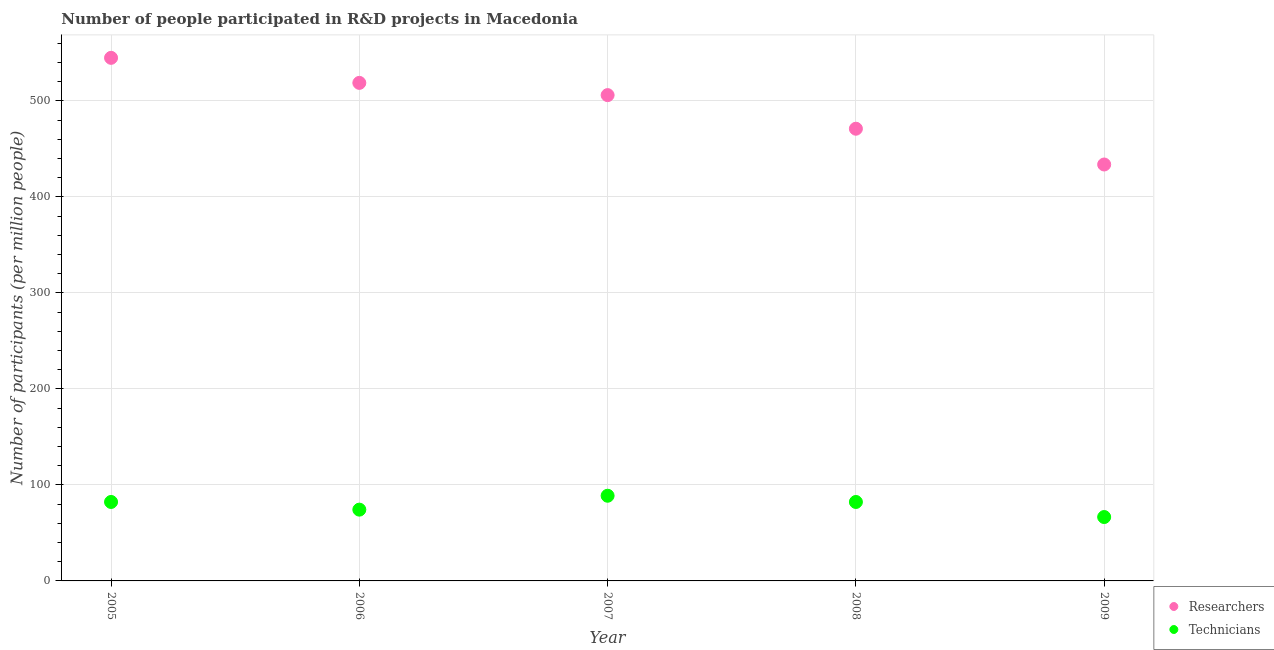What is the number of technicians in 2009?
Your response must be concise. 66.54. Across all years, what is the maximum number of technicians?
Give a very brief answer. 88.72. Across all years, what is the minimum number of researchers?
Provide a succinct answer. 433.72. What is the total number of researchers in the graph?
Your answer should be compact. 2474.24. What is the difference between the number of technicians in 2005 and that in 2007?
Offer a very short reply. -6.48. What is the difference between the number of researchers in 2007 and the number of technicians in 2005?
Keep it short and to the point. 423.75. What is the average number of technicians per year?
Your response must be concise. 78.79. In the year 2005, what is the difference between the number of researchers and number of technicians?
Offer a terse response. 462.58. In how many years, is the number of researchers greater than 100?
Make the answer very short. 5. What is the ratio of the number of researchers in 2007 to that in 2008?
Offer a terse response. 1.07. What is the difference between the highest and the second highest number of researchers?
Give a very brief answer. 26.09. What is the difference between the highest and the lowest number of researchers?
Your response must be concise. 111.09. Is the number of researchers strictly less than the number of technicians over the years?
Offer a very short reply. No. How many dotlines are there?
Offer a terse response. 2. How many years are there in the graph?
Make the answer very short. 5. Does the graph contain any zero values?
Keep it short and to the point. No. Does the graph contain grids?
Ensure brevity in your answer.  Yes. Where does the legend appear in the graph?
Your response must be concise. Bottom right. How many legend labels are there?
Offer a terse response. 2. How are the legend labels stacked?
Your answer should be compact. Vertical. What is the title of the graph?
Offer a very short reply. Number of people participated in R&D projects in Macedonia. What is the label or title of the Y-axis?
Offer a very short reply. Number of participants (per million people). What is the Number of participants (per million people) of Researchers in 2005?
Provide a short and direct response. 544.82. What is the Number of participants (per million people) of Technicians in 2005?
Give a very brief answer. 82.24. What is the Number of participants (per million people) of Researchers in 2006?
Give a very brief answer. 518.72. What is the Number of participants (per million people) of Technicians in 2006?
Offer a terse response. 74.24. What is the Number of participants (per million people) in Researchers in 2007?
Keep it short and to the point. 505.99. What is the Number of participants (per million people) of Technicians in 2007?
Provide a succinct answer. 88.72. What is the Number of participants (per million people) of Researchers in 2008?
Your response must be concise. 470.99. What is the Number of participants (per million people) of Technicians in 2008?
Your response must be concise. 82.23. What is the Number of participants (per million people) of Researchers in 2009?
Your answer should be very brief. 433.72. What is the Number of participants (per million people) of Technicians in 2009?
Provide a succinct answer. 66.54. Across all years, what is the maximum Number of participants (per million people) in Researchers?
Keep it short and to the point. 544.82. Across all years, what is the maximum Number of participants (per million people) of Technicians?
Ensure brevity in your answer.  88.72. Across all years, what is the minimum Number of participants (per million people) in Researchers?
Offer a very short reply. 433.72. Across all years, what is the minimum Number of participants (per million people) of Technicians?
Your answer should be compact. 66.54. What is the total Number of participants (per million people) in Researchers in the graph?
Offer a very short reply. 2474.24. What is the total Number of participants (per million people) in Technicians in the graph?
Give a very brief answer. 393.97. What is the difference between the Number of participants (per million people) in Researchers in 2005 and that in 2006?
Your answer should be compact. 26.09. What is the difference between the Number of participants (per million people) in Technicians in 2005 and that in 2006?
Provide a short and direct response. 7.99. What is the difference between the Number of participants (per million people) of Researchers in 2005 and that in 2007?
Your answer should be compact. 38.83. What is the difference between the Number of participants (per million people) of Technicians in 2005 and that in 2007?
Provide a short and direct response. -6.48. What is the difference between the Number of participants (per million people) of Researchers in 2005 and that in 2008?
Your answer should be compact. 73.83. What is the difference between the Number of participants (per million people) in Technicians in 2005 and that in 2008?
Make the answer very short. 0.01. What is the difference between the Number of participants (per million people) of Researchers in 2005 and that in 2009?
Provide a short and direct response. 111.09. What is the difference between the Number of participants (per million people) of Technicians in 2005 and that in 2009?
Keep it short and to the point. 15.7. What is the difference between the Number of participants (per million people) in Researchers in 2006 and that in 2007?
Keep it short and to the point. 12.74. What is the difference between the Number of participants (per million people) of Technicians in 2006 and that in 2007?
Offer a very short reply. -14.48. What is the difference between the Number of participants (per million people) of Researchers in 2006 and that in 2008?
Give a very brief answer. 47.74. What is the difference between the Number of participants (per million people) in Technicians in 2006 and that in 2008?
Your answer should be very brief. -7.98. What is the difference between the Number of participants (per million people) of Researchers in 2006 and that in 2009?
Your answer should be very brief. 85. What is the difference between the Number of participants (per million people) of Technicians in 2006 and that in 2009?
Keep it short and to the point. 7.7. What is the difference between the Number of participants (per million people) of Researchers in 2007 and that in 2008?
Your response must be concise. 35. What is the difference between the Number of participants (per million people) in Technicians in 2007 and that in 2008?
Offer a very short reply. 6.49. What is the difference between the Number of participants (per million people) in Researchers in 2007 and that in 2009?
Ensure brevity in your answer.  72.27. What is the difference between the Number of participants (per million people) of Technicians in 2007 and that in 2009?
Offer a terse response. 22.18. What is the difference between the Number of participants (per million people) of Researchers in 2008 and that in 2009?
Offer a very short reply. 37.26. What is the difference between the Number of participants (per million people) in Technicians in 2008 and that in 2009?
Offer a terse response. 15.69. What is the difference between the Number of participants (per million people) in Researchers in 2005 and the Number of participants (per million people) in Technicians in 2006?
Your answer should be compact. 470.57. What is the difference between the Number of participants (per million people) of Researchers in 2005 and the Number of participants (per million people) of Technicians in 2007?
Keep it short and to the point. 456.1. What is the difference between the Number of participants (per million people) of Researchers in 2005 and the Number of participants (per million people) of Technicians in 2008?
Provide a succinct answer. 462.59. What is the difference between the Number of participants (per million people) in Researchers in 2005 and the Number of participants (per million people) in Technicians in 2009?
Offer a terse response. 478.28. What is the difference between the Number of participants (per million people) in Researchers in 2006 and the Number of participants (per million people) in Technicians in 2007?
Provide a short and direct response. 430.01. What is the difference between the Number of participants (per million people) in Researchers in 2006 and the Number of participants (per million people) in Technicians in 2008?
Keep it short and to the point. 436.5. What is the difference between the Number of participants (per million people) in Researchers in 2006 and the Number of participants (per million people) in Technicians in 2009?
Your answer should be very brief. 452.18. What is the difference between the Number of participants (per million people) in Researchers in 2007 and the Number of participants (per million people) in Technicians in 2008?
Offer a terse response. 423.76. What is the difference between the Number of participants (per million people) in Researchers in 2007 and the Number of participants (per million people) in Technicians in 2009?
Ensure brevity in your answer.  439.45. What is the difference between the Number of participants (per million people) of Researchers in 2008 and the Number of participants (per million people) of Technicians in 2009?
Provide a succinct answer. 404.45. What is the average Number of participants (per million people) of Researchers per year?
Offer a terse response. 494.85. What is the average Number of participants (per million people) of Technicians per year?
Your response must be concise. 78.79. In the year 2005, what is the difference between the Number of participants (per million people) in Researchers and Number of participants (per million people) in Technicians?
Your response must be concise. 462.58. In the year 2006, what is the difference between the Number of participants (per million people) of Researchers and Number of participants (per million people) of Technicians?
Provide a succinct answer. 444.48. In the year 2007, what is the difference between the Number of participants (per million people) of Researchers and Number of participants (per million people) of Technicians?
Your answer should be very brief. 417.27. In the year 2008, what is the difference between the Number of participants (per million people) in Researchers and Number of participants (per million people) in Technicians?
Your answer should be compact. 388.76. In the year 2009, what is the difference between the Number of participants (per million people) in Researchers and Number of participants (per million people) in Technicians?
Your answer should be compact. 367.18. What is the ratio of the Number of participants (per million people) in Researchers in 2005 to that in 2006?
Provide a short and direct response. 1.05. What is the ratio of the Number of participants (per million people) in Technicians in 2005 to that in 2006?
Give a very brief answer. 1.11. What is the ratio of the Number of participants (per million people) of Researchers in 2005 to that in 2007?
Provide a succinct answer. 1.08. What is the ratio of the Number of participants (per million people) in Technicians in 2005 to that in 2007?
Keep it short and to the point. 0.93. What is the ratio of the Number of participants (per million people) of Researchers in 2005 to that in 2008?
Give a very brief answer. 1.16. What is the ratio of the Number of participants (per million people) of Researchers in 2005 to that in 2009?
Provide a short and direct response. 1.26. What is the ratio of the Number of participants (per million people) in Technicians in 2005 to that in 2009?
Your answer should be compact. 1.24. What is the ratio of the Number of participants (per million people) in Researchers in 2006 to that in 2007?
Offer a very short reply. 1.03. What is the ratio of the Number of participants (per million people) of Technicians in 2006 to that in 2007?
Ensure brevity in your answer.  0.84. What is the ratio of the Number of participants (per million people) in Researchers in 2006 to that in 2008?
Offer a terse response. 1.1. What is the ratio of the Number of participants (per million people) of Technicians in 2006 to that in 2008?
Your response must be concise. 0.9. What is the ratio of the Number of participants (per million people) in Researchers in 2006 to that in 2009?
Keep it short and to the point. 1.2. What is the ratio of the Number of participants (per million people) of Technicians in 2006 to that in 2009?
Provide a succinct answer. 1.12. What is the ratio of the Number of participants (per million people) in Researchers in 2007 to that in 2008?
Give a very brief answer. 1.07. What is the ratio of the Number of participants (per million people) of Technicians in 2007 to that in 2008?
Keep it short and to the point. 1.08. What is the ratio of the Number of participants (per million people) of Researchers in 2007 to that in 2009?
Make the answer very short. 1.17. What is the ratio of the Number of participants (per million people) in Researchers in 2008 to that in 2009?
Your answer should be very brief. 1.09. What is the ratio of the Number of participants (per million people) in Technicians in 2008 to that in 2009?
Make the answer very short. 1.24. What is the difference between the highest and the second highest Number of participants (per million people) in Researchers?
Your answer should be very brief. 26.09. What is the difference between the highest and the second highest Number of participants (per million people) of Technicians?
Your response must be concise. 6.48. What is the difference between the highest and the lowest Number of participants (per million people) in Researchers?
Offer a very short reply. 111.09. What is the difference between the highest and the lowest Number of participants (per million people) in Technicians?
Keep it short and to the point. 22.18. 